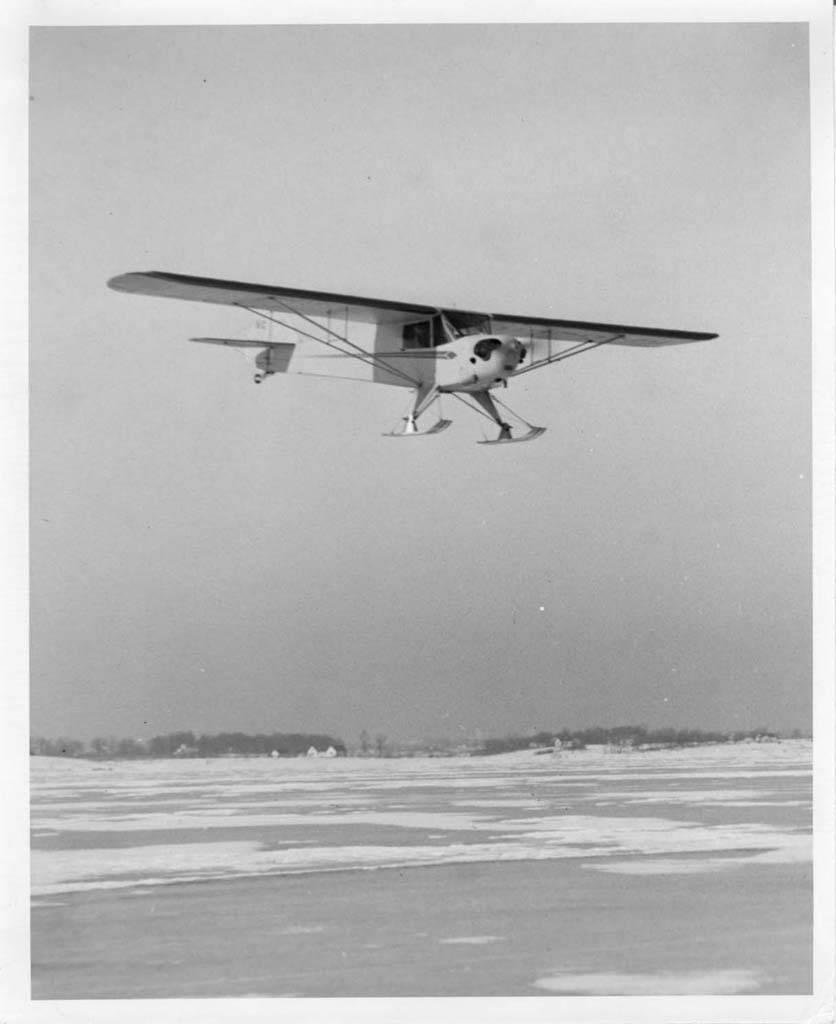What is the color scheme of the image? The image is a black and white picture. What is the main subject of the image? There is an airplane in the image. What is the airplane doing in the image? The airplane is flying in the sky. What can be seen in the background of the image? There is a group of trees and water visible in the background of the image. What type of quill is being used by the airplane pilot in the image? There is no quill present in the image, as airplanes typically use modern instruments for navigation and communication. What flavor of pie is being served to the passengers on the airplane in the image? There is no pie visible in the image, and it does not mention any food being served on the airplane. 